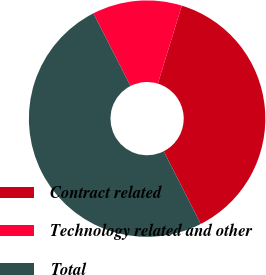Convert chart to OTSL. <chart><loc_0><loc_0><loc_500><loc_500><pie_chart><fcel>Contract related<fcel>Technology related and other<fcel>Total<nl><fcel>37.76%<fcel>12.24%<fcel>50.0%<nl></chart> 